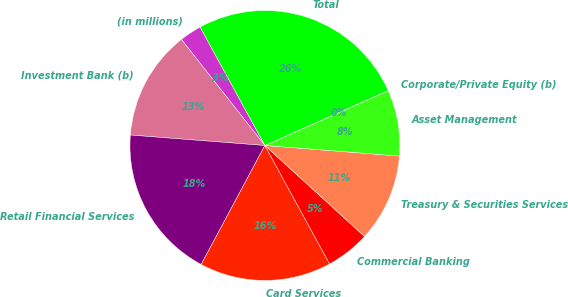Convert chart to OTSL. <chart><loc_0><loc_0><loc_500><loc_500><pie_chart><fcel>(in millions)<fcel>Investment Bank (b)<fcel>Retail Financial Services<fcel>Card Services<fcel>Commercial Banking<fcel>Treasury & Securities Services<fcel>Asset Management<fcel>Corporate/Private Equity (b)<fcel>Total<nl><fcel>2.65%<fcel>13.15%<fcel>18.41%<fcel>15.78%<fcel>5.27%<fcel>10.53%<fcel>7.9%<fcel>0.02%<fcel>26.29%<nl></chart> 